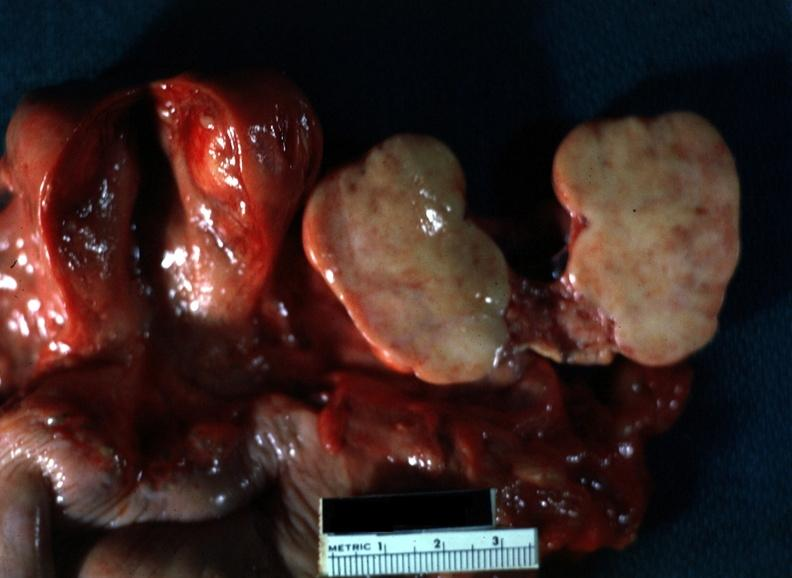does this image show close-up of lesion sliced open like a book typical for this lesion with yellow foci evident view of all pelvic organ in slide?
Answer the question using a single word or phrase. Yes 